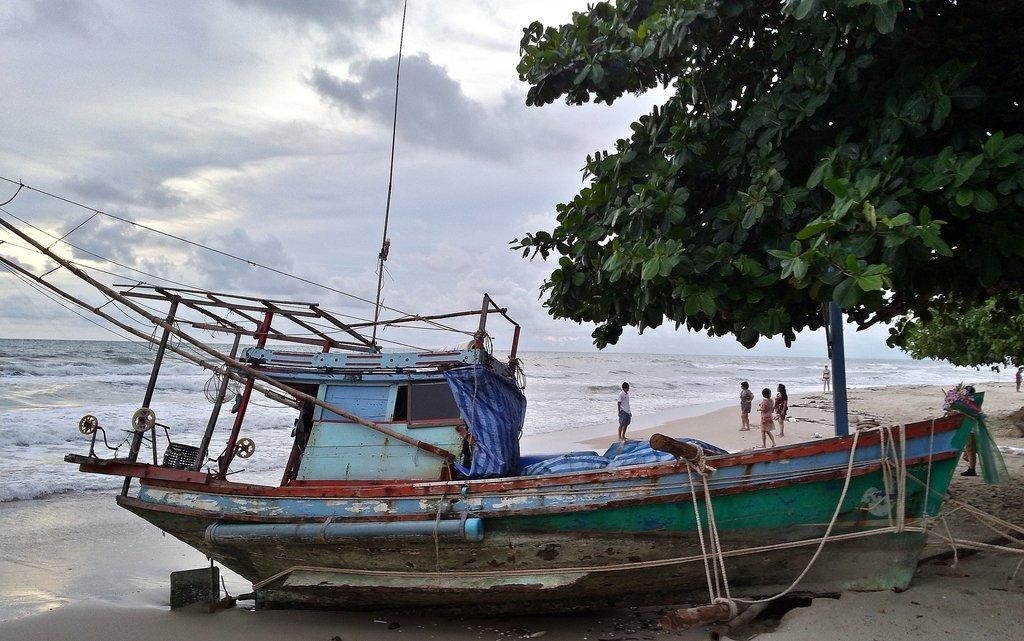How would you summarize this image in a sentence or two? In this picture we can see the sky and it seems like a cloudy day. We can see people near to the sea shore. In this picture we can see the sea, boat and ropes. On the right side we can see the trees and at the bottom we can see the sand. 